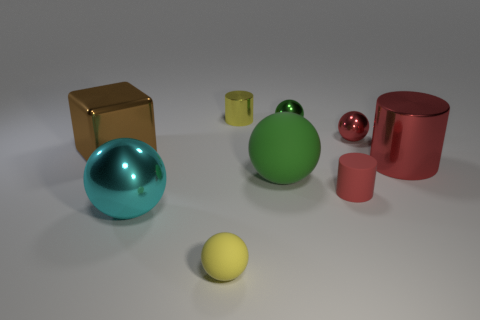Do the cyan object and the yellow matte object have the same size?
Your answer should be compact. No. Is there anything else of the same color as the big rubber ball?
Provide a succinct answer. Yes. There is a big metallic object that is in front of the tiny rubber thing to the right of the yellow object that is behind the big green object; what is its shape?
Provide a short and direct response. Sphere. There is a tiny matte thing that is the same shape as the large red thing; what is its color?
Your answer should be very brief. Red. The tiny rubber thing that is right of the metallic cylinder that is behind the cube is what color?
Offer a very short reply. Red. What is the size of the red metallic object that is the same shape as the large green rubber thing?
Keep it short and to the point. Small. How many cyan balls have the same material as the big red thing?
Keep it short and to the point. 1. How many green shiny balls are to the left of the tiny matte object that is on the left side of the yellow cylinder?
Make the answer very short. 0. Are there any yellow objects on the right side of the tiny yellow shiny thing?
Your response must be concise. No. There is a large object that is in front of the small red rubber object; is it the same shape as the small red matte object?
Provide a succinct answer. No. 